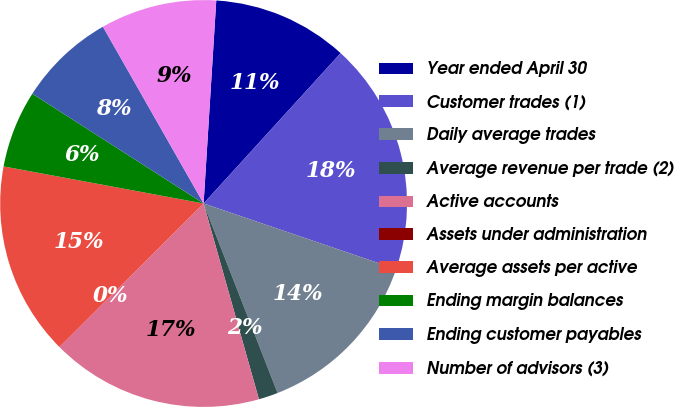Convert chart. <chart><loc_0><loc_0><loc_500><loc_500><pie_chart><fcel>Year ended April 30<fcel>Customer trades (1)<fcel>Daily average trades<fcel>Average revenue per trade (2)<fcel>Active accounts<fcel>Assets under administration<fcel>Average assets per active<fcel>Ending margin balances<fcel>Ending customer payables<fcel>Number of advisors (3)<nl><fcel>10.77%<fcel>18.46%<fcel>13.85%<fcel>1.54%<fcel>16.92%<fcel>0.0%<fcel>15.38%<fcel>6.15%<fcel>7.69%<fcel>9.23%<nl></chart> 